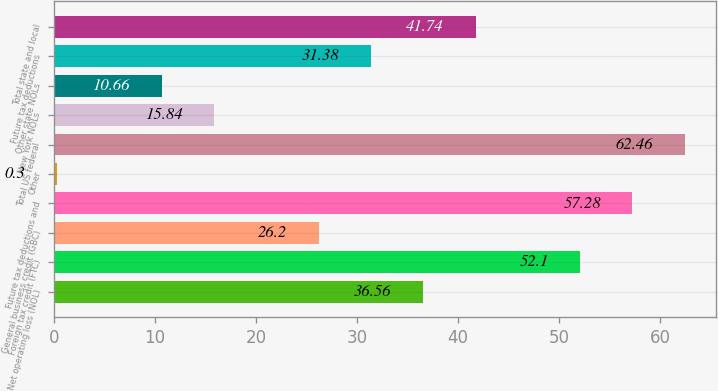<chart> <loc_0><loc_0><loc_500><loc_500><bar_chart><fcel>Net operating loss (NOL)<fcel>Foreign tax credit (FTC)<fcel>General business credit (GBC)<fcel>Future tax deductions and<fcel>Other<fcel>Total US federal<fcel>New York NOLs<fcel>Other state NOLs<fcel>Future tax deductions<fcel>Total state and local<nl><fcel>36.56<fcel>52.1<fcel>26.2<fcel>57.28<fcel>0.3<fcel>62.46<fcel>15.84<fcel>10.66<fcel>31.38<fcel>41.74<nl></chart> 